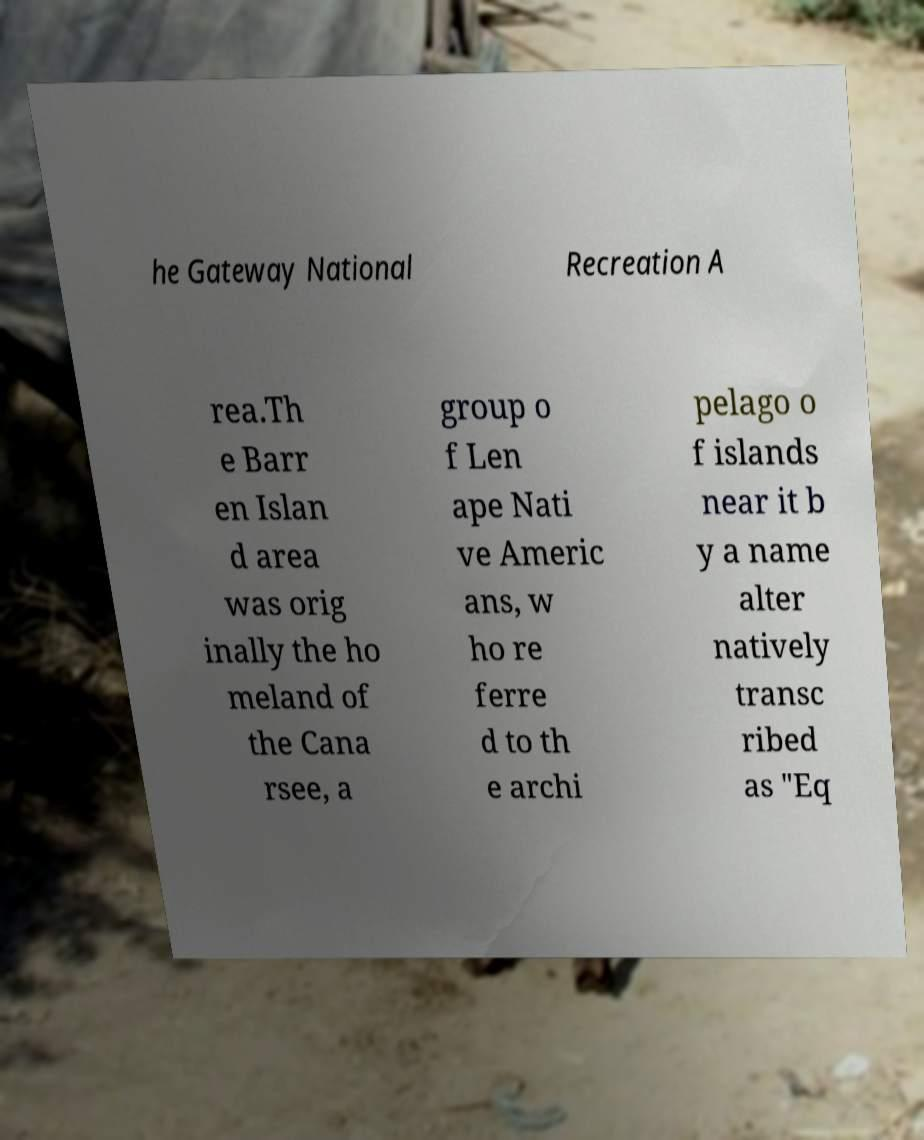Can you read and provide the text displayed in the image?This photo seems to have some interesting text. Can you extract and type it out for me? he Gateway National Recreation A rea.Th e Barr en Islan d area was orig inally the ho meland of the Cana rsee, a group o f Len ape Nati ve Americ ans, w ho re ferre d to th e archi pelago o f islands near it b y a name alter natively transc ribed as "Eq 